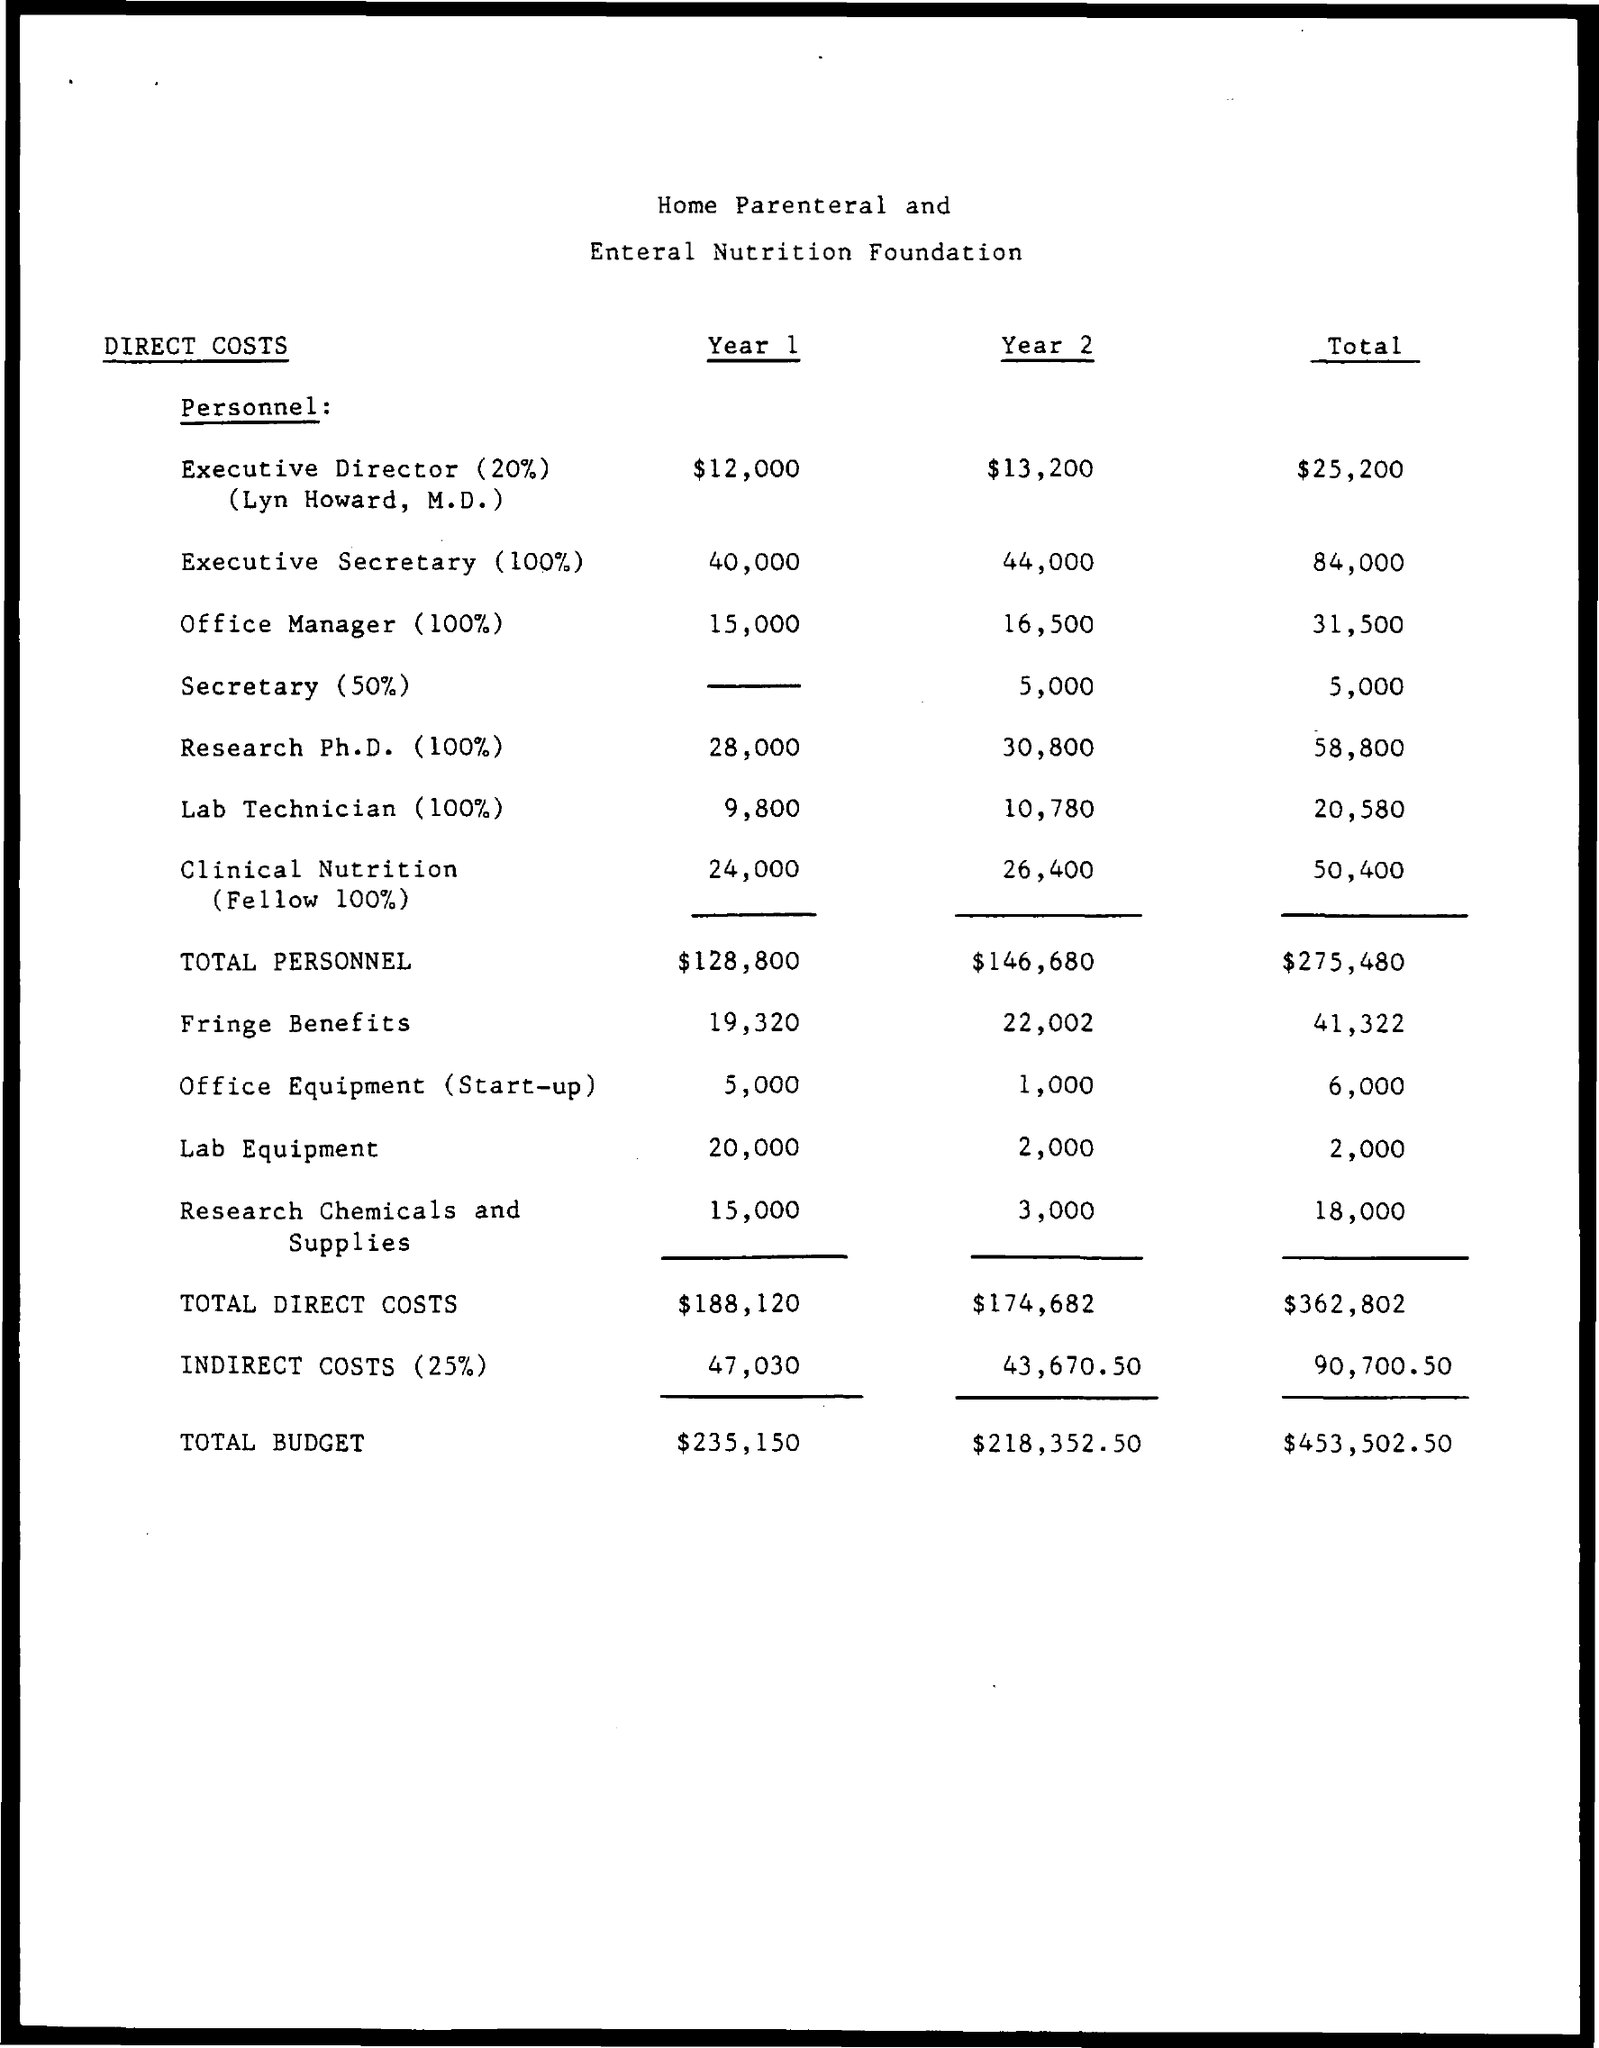What is the amount of total direct costs in year 1 ?
Give a very brief answer. $ 188,120. What is the amount of total direct costs in year 2 ?
Give a very brief answer. $174,682. What is the total amount of total direct costs ?
Ensure brevity in your answer.  $362,802. What is the amount of indirect costs(25%) for year 1 ?
Make the answer very short. 47,030. What is the amount of indirect costs (25%) for year 2 ?
Keep it short and to the point. $ 43,670.50. What is the total amount for the indirect costs(25%) ?
Your answer should be compact. $ 90,700.50. What is the total budget in year 1?
Offer a very short reply. $ 235,150. What is the total budget for year 2?
Offer a very short reply. $ 218,352.50. What is the total budget mentioned in the given page ?
Make the answer very short. $453,502.50. 